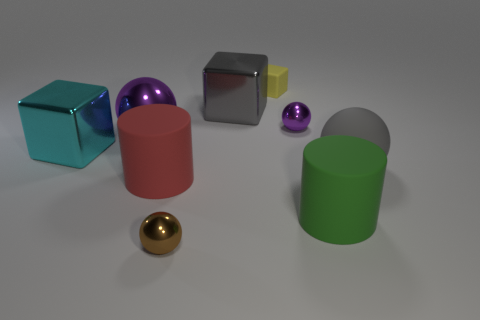What is the color of the metal sphere in front of the big gray rubber ball?
Offer a very short reply. Brown. There is a ball that is in front of the big purple metal object and to the left of the large gray sphere; what is it made of?
Provide a succinct answer. Metal. There is a tiny thing that is behind the gray metallic block; what number of green matte cylinders are right of it?
Keep it short and to the point. 1. What is the shape of the large gray matte object?
Provide a short and direct response. Sphere. There is a large red object that is the same material as the tiny yellow object; what is its shape?
Your answer should be compact. Cylinder. Do the tiny thing in front of the big green object and the tiny yellow thing have the same shape?
Your answer should be compact. No. There is a big green thing that is on the right side of the small purple metallic thing; what is its shape?
Give a very brief answer. Cylinder. The big metal object that is the same color as the large rubber sphere is what shape?
Your answer should be compact. Cube. What number of blocks have the same size as the brown object?
Offer a very short reply. 1. What color is the rubber ball?
Your response must be concise. Gray. 